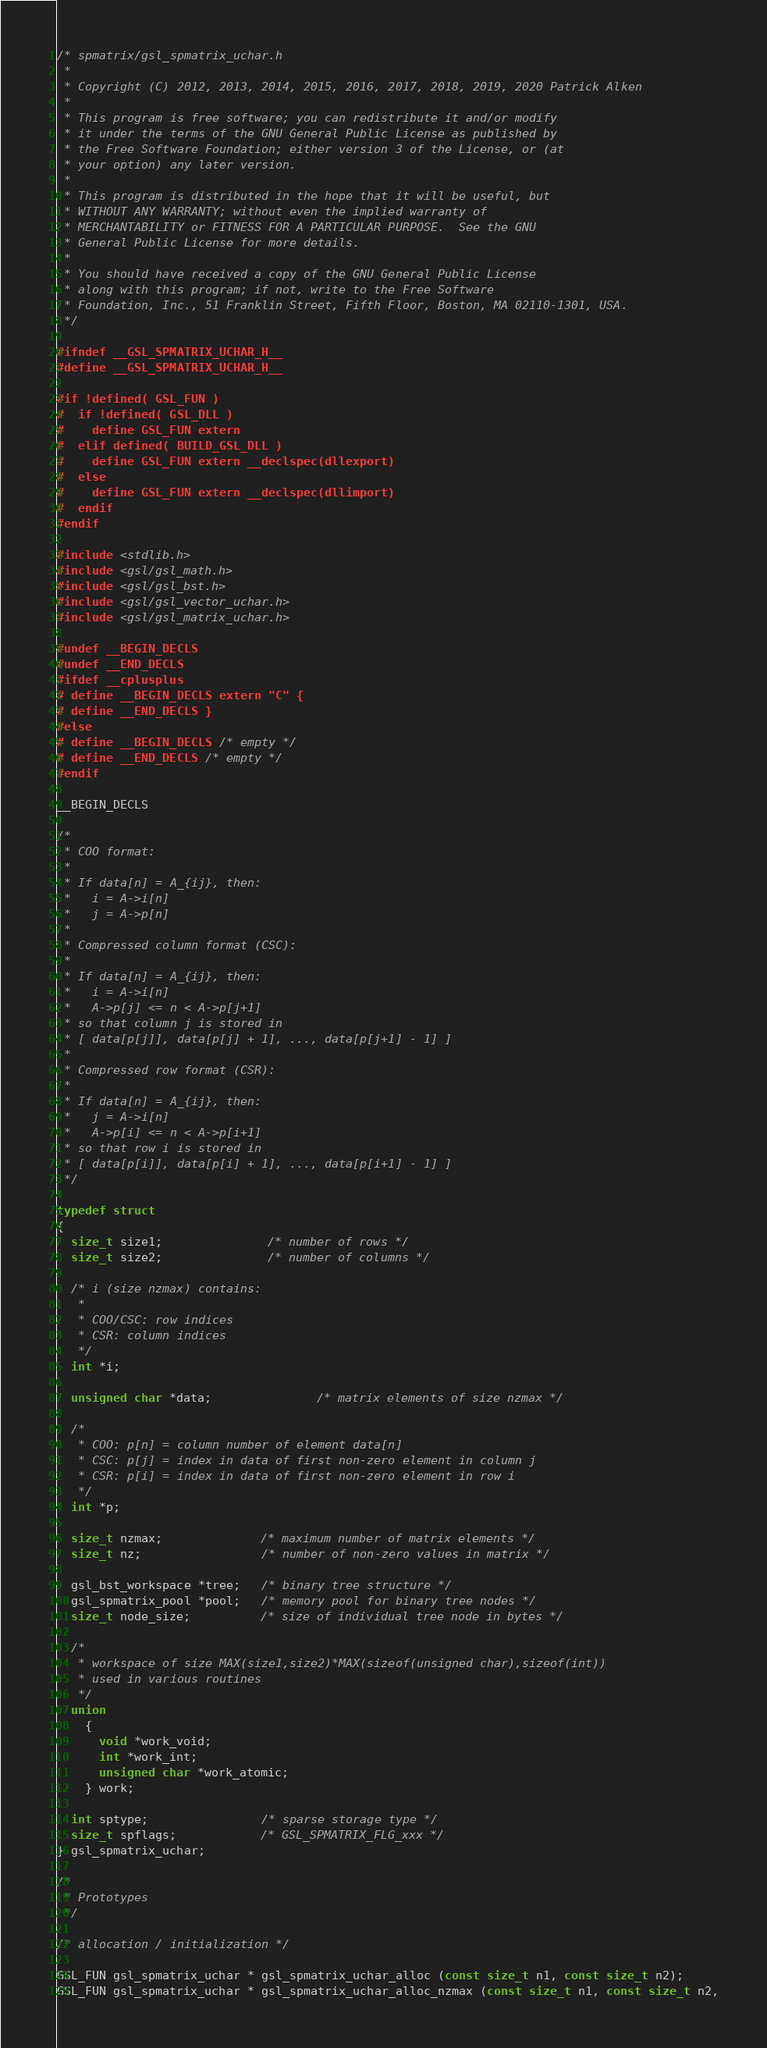<code> <loc_0><loc_0><loc_500><loc_500><_C_>/* spmatrix/gsl_spmatrix_uchar.h
 * 
 * Copyright (C) 2012, 2013, 2014, 2015, 2016, 2017, 2018, 2019, 2020 Patrick Alken
 * 
 * This program is free software; you can redistribute it and/or modify
 * it under the terms of the GNU General Public License as published by
 * the Free Software Foundation; either version 3 of the License, or (at
 * your option) any later version.
 * 
 * This program is distributed in the hope that it will be useful, but
 * WITHOUT ANY WARRANTY; without even the implied warranty of
 * MERCHANTABILITY or FITNESS FOR A PARTICULAR PURPOSE.  See the GNU
 * General Public License for more details.
 * 
 * You should have received a copy of the GNU General Public License
 * along with this program; if not, write to the Free Software
 * Foundation, Inc., 51 Franklin Street, Fifth Floor, Boston, MA 02110-1301, USA.
 */

#ifndef __GSL_SPMATRIX_UCHAR_H__
#define __GSL_SPMATRIX_UCHAR_H__

#if !defined( GSL_FUN )
#  if !defined( GSL_DLL )
#    define GSL_FUN extern
#  elif defined( BUILD_GSL_DLL )
#    define GSL_FUN extern __declspec(dllexport)
#  else
#    define GSL_FUN extern __declspec(dllimport)
#  endif
#endif

#include <stdlib.h>
#include <gsl/gsl_math.h>
#include <gsl/gsl_bst.h>
#include <gsl/gsl_vector_uchar.h>
#include <gsl/gsl_matrix_uchar.h>

#undef __BEGIN_DECLS
#undef __END_DECLS
#ifdef __cplusplus
# define __BEGIN_DECLS extern "C" {
# define __END_DECLS }
#else
# define __BEGIN_DECLS /* empty */
# define __END_DECLS /* empty */
#endif

__BEGIN_DECLS

/*
 * COO format:
 *
 * If data[n] = A_{ij}, then:
 *   i = A->i[n]
 *   j = A->p[n]
 *
 * Compressed column format (CSC):
 *
 * If data[n] = A_{ij}, then:
 *   i = A->i[n]
 *   A->p[j] <= n < A->p[j+1]
 * so that column j is stored in
 * [ data[p[j]], data[p[j] + 1], ..., data[p[j+1] - 1] ]
 *
 * Compressed row format (CSR):
 *
 * If data[n] = A_{ij}, then:
 *   j = A->i[n]
 *   A->p[i] <= n < A->p[i+1]
 * so that row i is stored in
 * [ data[p[i]], data[p[i] + 1], ..., data[p[i+1] - 1] ]
 */

typedef struct
{
  size_t size1;               /* number of rows */
  size_t size2;               /* number of columns */

  /* i (size nzmax) contains:
   *
   * COO/CSC: row indices
   * CSR: column indices
   */
  int *i;

  unsigned char *data;               /* matrix elements of size nzmax */

  /*
   * COO: p[n] = column number of element data[n]
   * CSC: p[j] = index in data of first non-zero element in column j
   * CSR: p[i] = index in data of first non-zero element in row i
   */
  int *p;

  size_t nzmax;              /* maximum number of matrix elements */
  size_t nz;                 /* number of non-zero values in matrix */

  gsl_bst_workspace *tree;   /* binary tree structure */
  gsl_spmatrix_pool *pool;   /* memory pool for binary tree nodes */
  size_t node_size;          /* size of individual tree node in bytes */

  /*
   * workspace of size MAX(size1,size2)*MAX(sizeof(unsigned char),sizeof(int))
   * used in various routines
   */
  union
    {
      void *work_void;
      int *work_int;
      unsigned char *work_atomic;
    } work;

  int sptype;                /* sparse storage type */
  size_t spflags;            /* GSL_SPMATRIX_FLG_xxx */
} gsl_spmatrix_uchar;

/*
 * Prototypes
 */

/* allocation / initialization */

GSL_FUN gsl_spmatrix_uchar * gsl_spmatrix_uchar_alloc (const size_t n1, const size_t n2);
GSL_FUN gsl_spmatrix_uchar * gsl_spmatrix_uchar_alloc_nzmax (const size_t n1, const size_t n2,</code> 